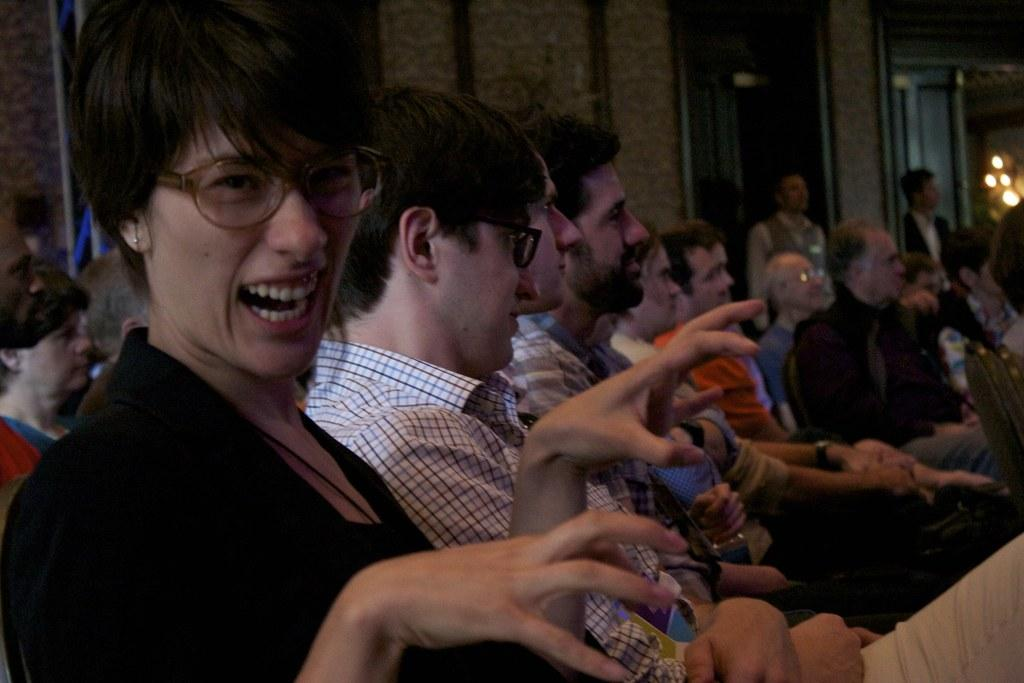What is happening in the room in the image? There are people sitting in the room. What can be seen providing illumination in the room? There are lights in the room. What is visible in the background of the image? There is a wall in the background. What type of crow is sitting on the letters in the image? There is no crow or letters present in the image. 